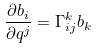Convert formula to latex. <formula><loc_0><loc_0><loc_500><loc_500>\frac { \partial b _ { i } } { \partial q ^ { j } } = \Gamma _ { i j } ^ { k } b _ { k }</formula> 